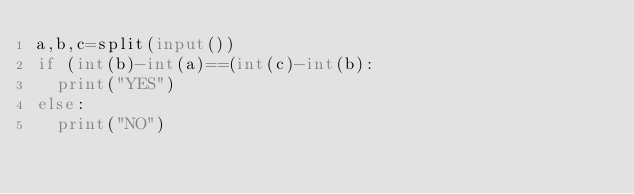Convert code to text. <code><loc_0><loc_0><loc_500><loc_500><_Python_>a,b,c=split(input())
if (int(b)-int(a)==(int(c)-int(b):
	print("YES")
else:
	print("NO")</code> 